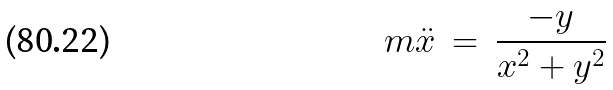Convert formula to latex. <formula><loc_0><loc_0><loc_500><loc_500>m \ddot { x } \, = \, \frac { - y } { x ^ { 2 } + y ^ { 2 } }</formula> 